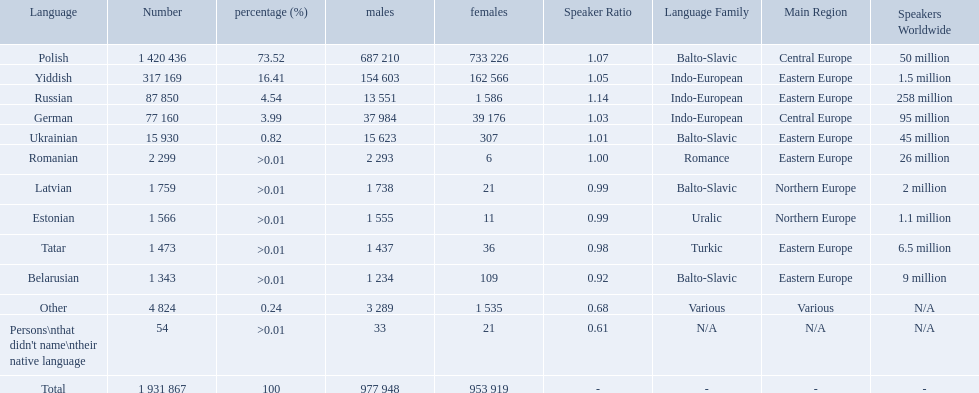What named native languages spoken in the warsaw governorate have more males then females? Russian, Ukrainian, Romanian, Latvian, Estonian, Tatar, Belarusian. Which of those have less then 500 males listed? Romanian, Latvian, Estonian, Tatar, Belarusian. Of the remaining languages which of them have less then 20 females? Romanian, Estonian. Which of these has the highest total number listed? Romanian. What are all the languages? Polish, Yiddish, Russian, German, Ukrainian, Romanian, Latvian, Estonian, Tatar, Belarusian, Other, Persons\nthat didn't name\ntheir native language. Of those languages, which five had fewer than 50 females speaking it? 6, 21, 11, 36, 21. Of those five languages, which is the lowest? Romanian. What are the languages of the warsaw governorate? Polish, Yiddish, Russian, German, Ukrainian, Romanian, Latvian, Estonian, Tatar, Belarusian, Other. What is the percentage of polish? 73.52. What is the next highest amount? 16.41. What is the language with this amount? Yiddish. Would you be able to parse every entry in this table? {'header': ['Language', 'Number', 'percentage (%)', 'males', 'females', 'Speaker Ratio', 'Language Family', 'Main Region', 'Speakers Worldwide'], 'rows': [['Polish', '1 420 436', '73.52', '687 210', '733 226', '1.07', 'Balto-Slavic', 'Central Europe', '50 million'], ['Yiddish', '317 169', '16.41', '154 603', '162 566', '1.05', 'Indo-European', 'Eastern Europe', '1.5 million'], ['Russian', '87 850', '4.54', '13 551', '1 586', '1.14', 'Indo-European', 'Eastern Europe', '258 million'], ['German', '77 160', '3.99', '37 984', '39 176', '1.03', 'Indo-European', 'Central Europe', '95 million'], ['Ukrainian', '15 930', '0.82', '15 623', '307', '1.01', 'Balto-Slavic', 'Eastern Europe', '45 million'], ['Romanian', '2 299', '>0.01', '2 293', '6', '1.00', 'Romance', 'Eastern Europe', '26 million'], ['Latvian', '1 759', '>0.01', '1 738', '21', '0.99', 'Balto-Slavic', 'Northern Europe', '2 million'], ['Estonian', '1 566', '>0.01', '1 555', '11', '0.99', 'Uralic', 'Northern Europe', '1.1 million'], ['Tatar', '1 473', '>0.01', '1 437', '36', '0.98', 'Turkic', 'Eastern Europe', '6.5 million'], ['Belarusian', '1 343', '>0.01', '1 234', '109', '0.92', 'Balto-Slavic', 'Eastern Europe', '9 million'], ['Other', '4 824', '0.24', '3 289', '1 535', '0.68', 'Various', 'Various', 'N/A'], ["Persons\\nthat didn't name\\ntheir native language", '54', '>0.01', '33', '21', '0.61', 'N/A', 'N/A', 'N/A'], ['Total', '1 931 867', '100', '977 948', '953 919', '-', '-', '-', '-']]} How many languages are there? Polish, Yiddish, Russian, German, Ukrainian, Romanian, Latvian, Estonian, Tatar, Belarusian. Which language do more people speak? Polish. What are all the spoken languages? Polish, Yiddish, Russian, German, Ukrainian, Romanian, Latvian, Estonian, Tatar, Belarusian. Which one of these has the most people speaking it? Polish. What are all the languages? Polish, Yiddish, Russian, German, Ukrainian, Romanian, Latvian, Estonian, Tatar, Belarusian, Other. Give me the full table as a dictionary. {'header': ['Language', 'Number', 'percentage (%)', 'males', 'females', 'Speaker Ratio', 'Language Family', 'Main Region', 'Speakers Worldwide'], 'rows': [['Polish', '1 420 436', '73.52', '687 210', '733 226', '1.07', 'Balto-Slavic', 'Central Europe', '50 million'], ['Yiddish', '317 169', '16.41', '154 603', '162 566', '1.05', 'Indo-European', 'Eastern Europe', '1.5 million'], ['Russian', '87 850', '4.54', '13 551', '1 586', '1.14', 'Indo-European', 'Eastern Europe', '258 million'], ['German', '77 160', '3.99', '37 984', '39 176', '1.03', 'Indo-European', 'Central Europe', '95 million'], ['Ukrainian', '15 930', '0.82', '15 623', '307', '1.01', 'Balto-Slavic', 'Eastern Europe', '45 million'], ['Romanian', '2 299', '>0.01', '2 293', '6', '1.00', 'Romance', 'Eastern Europe', '26 million'], ['Latvian', '1 759', '>0.01', '1 738', '21', '0.99', 'Balto-Slavic', 'Northern Europe', '2 million'], ['Estonian', '1 566', '>0.01', '1 555', '11', '0.99', 'Uralic', 'Northern Europe', '1.1 million'], ['Tatar', '1 473', '>0.01', '1 437', '36', '0.98', 'Turkic', 'Eastern Europe', '6.5 million'], ['Belarusian', '1 343', '>0.01', '1 234', '109', '0.92', 'Balto-Slavic', 'Eastern Europe', '9 million'], ['Other', '4 824', '0.24', '3 289', '1 535', '0.68', 'Various', 'Various', 'N/A'], ["Persons\\nthat didn't name\\ntheir native language", '54', '>0.01', '33', '21', '0.61', 'N/A', 'N/A', 'N/A'], ['Total', '1 931 867', '100', '977 948', '953 919', '-', '-', '-', '-']]} Which only have percentages >0.01? Romanian, Latvian, Estonian, Tatar, Belarusian. Of these, which has the greatest number of speakers? Romanian. Which languages are spoken by more than 50,000 people? Polish, Yiddish, Russian, German. Of these languages, which ones are spoken by less than 15% of the population? Russian, German. Of the remaining two, which one is spoken by 37,984 males? German. 